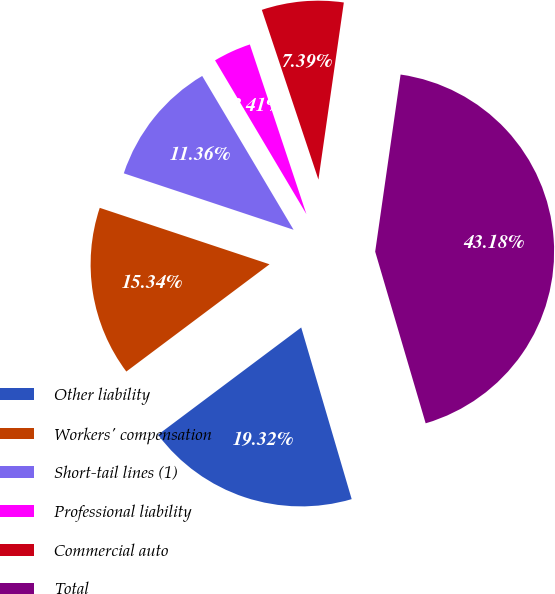Convert chart to OTSL. <chart><loc_0><loc_0><loc_500><loc_500><pie_chart><fcel>Other liability<fcel>Workers' compensation<fcel>Short-tail lines (1)<fcel>Professional liability<fcel>Commercial auto<fcel>Total<nl><fcel>19.32%<fcel>15.34%<fcel>11.36%<fcel>3.41%<fcel>7.39%<fcel>43.18%<nl></chart> 